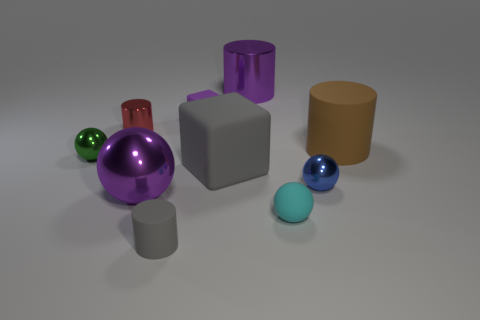Subtract all purple spheres. How many spheres are left? 3 Subtract all purple balls. How many balls are left? 3 Subtract all cylinders. How many objects are left? 6 Subtract 3 cylinders. How many cylinders are left? 1 Add 1 large metal things. How many large metal things exist? 3 Subtract 1 purple balls. How many objects are left? 9 Subtract all blue cylinders. Subtract all brown spheres. How many cylinders are left? 4 Subtract all red blocks. How many yellow cylinders are left? 0 Subtract all small purple blocks. Subtract all purple metallic cylinders. How many objects are left? 8 Add 4 metallic things. How many metallic things are left? 9 